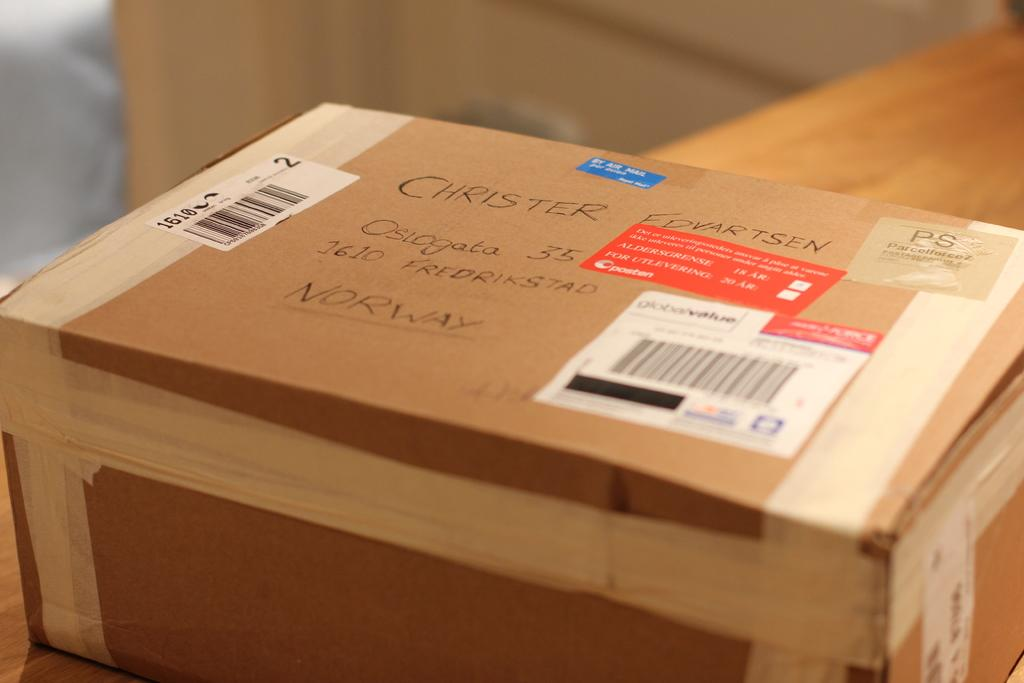<image>
Summarize the visual content of the image. a box with labels on it addressed to Christer Edvartsen 